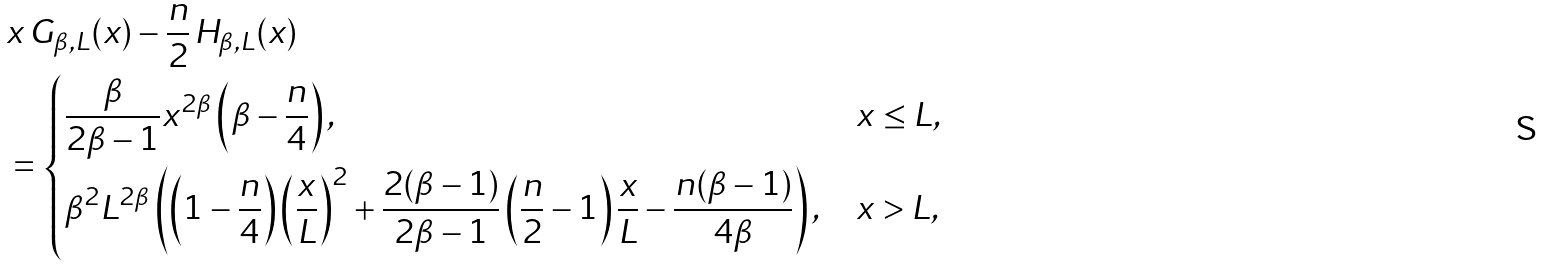Convert formula to latex. <formula><loc_0><loc_0><loc_500><loc_500>& x \, G _ { \beta , L } ( x ) - \frac { n } { 2 } \, H _ { \beta , L } ( x ) \\ & = \begin{dcases} \frac { \beta } { 2 \beta - 1 } x ^ { 2 \beta } \left ( \beta - \frac { n } { 4 } \right ) , & x \leq L , \\ \beta ^ { 2 } L ^ { 2 \beta } \left ( \left ( 1 - \frac { n } { 4 } \right ) \left ( \frac { x } { L } \right ) ^ { 2 } + \frac { 2 ( \beta - 1 ) } { 2 \beta - 1 } \left ( \frac { n } { 2 } - 1 \right ) \frac { x } { L } - \frac { n ( \beta - 1 ) } { 4 \beta } \right ) , & x > L , \end{dcases}</formula> 